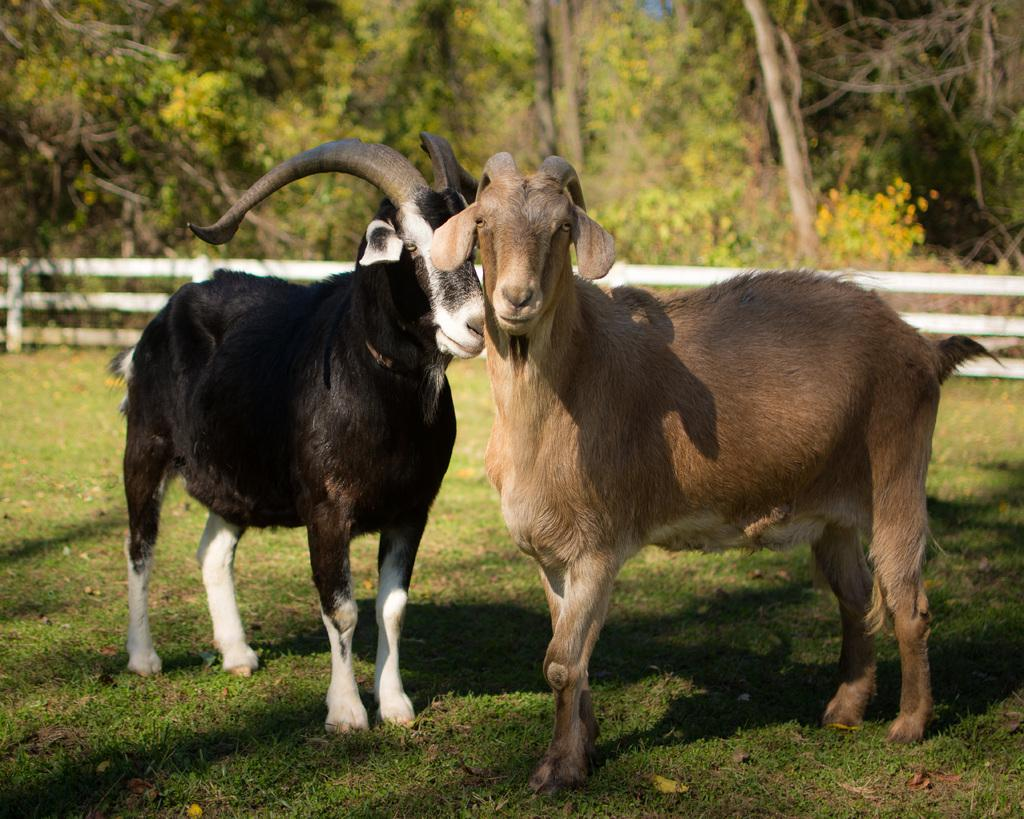How many goats are in the image? There are two goats in the image. Where are the goats located? The goats are on the grass. What is the structure visible from left to right in the image? There is fencing visible from left to right in the image. What can be seen in the background of the image? There are trees visible in the background of the image. What type of bird can be heard singing in the image? There is no bird present in the image, and therefore no singing can be heard. 